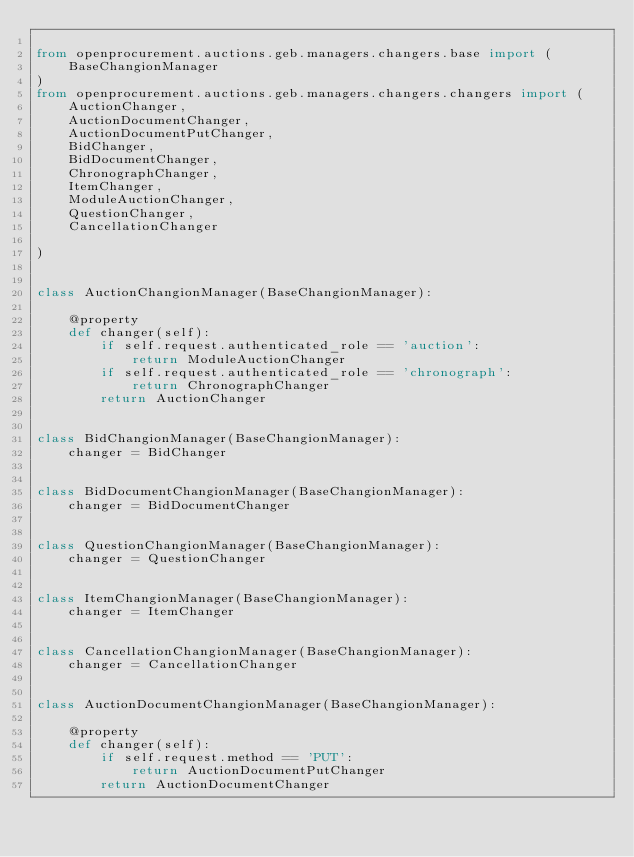Convert code to text. <code><loc_0><loc_0><loc_500><loc_500><_Python_>
from openprocurement.auctions.geb.managers.changers.base import (
    BaseChangionManager
)
from openprocurement.auctions.geb.managers.changers.changers import (
    AuctionChanger,
    AuctionDocumentChanger,
    AuctionDocumentPutChanger,
    BidChanger,
    BidDocumentChanger,
    ChronographChanger,
    ItemChanger,
    ModuleAuctionChanger,
    QuestionChanger,
    CancellationChanger

)


class AuctionChangionManager(BaseChangionManager):

    @property
    def changer(self):
        if self.request.authenticated_role == 'auction':
            return ModuleAuctionChanger
        if self.request.authenticated_role == 'chronograph':
            return ChronographChanger
        return AuctionChanger


class BidChangionManager(BaseChangionManager):
    changer = BidChanger


class BidDocumentChangionManager(BaseChangionManager):
    changer = BidDocumentChanger


class QuestionChangionManager(BaseChangionManager):
    changer = QuestionChanger


class ItemChangionManager(BaseChangionManager):
    changer = ItemChanger


class CancellationChangionManager(BaseChangionManager):
    changer = CancellationChanger


class AuctionDocumentChangionManager(BaseChangionManager):

    @property
    def changer(self):
        if self.request.method == 'PUT':
            return AuctionDocumentPutChanger
        return AuctionDocumentChanger
</code> 